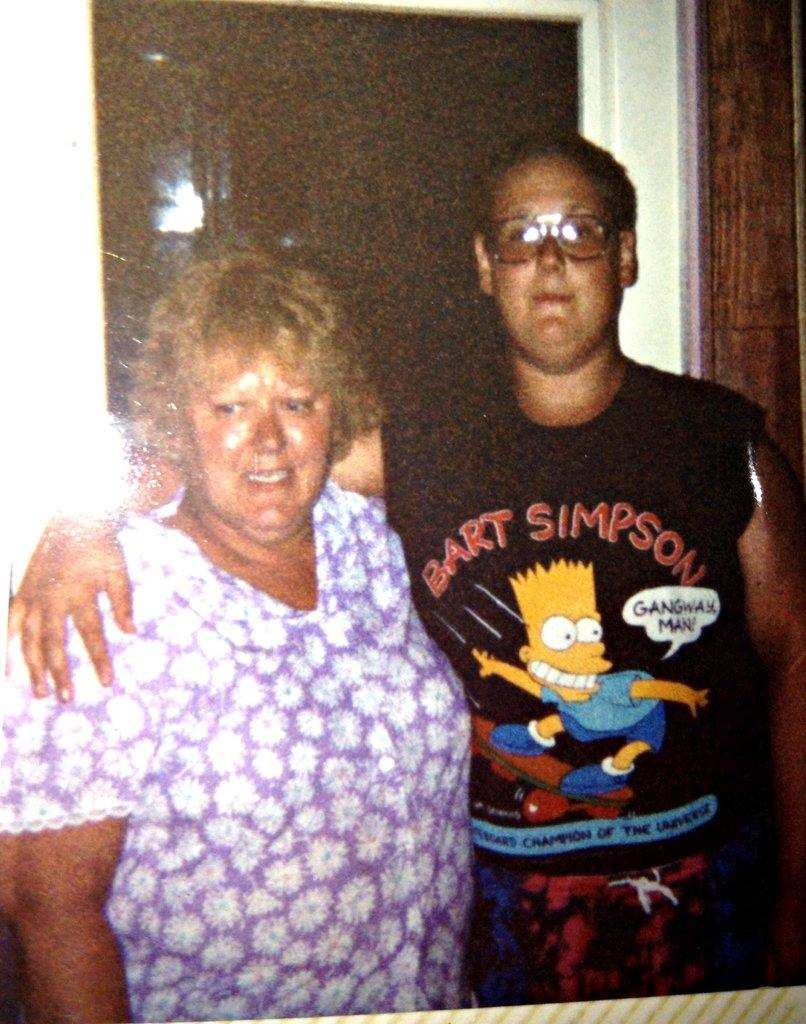How many people are in the image? There are two people standing in the image. What can be seen in the background of the image? There is a glass window, a wall, and a wooden board in the background of the image. What is the surface on which the photograph is placed? The photograph is placed on a surface with white and green lines. What type of linen is used to create the caption for the image? There is no caption present in the image, and therefore no linen is used for it. 